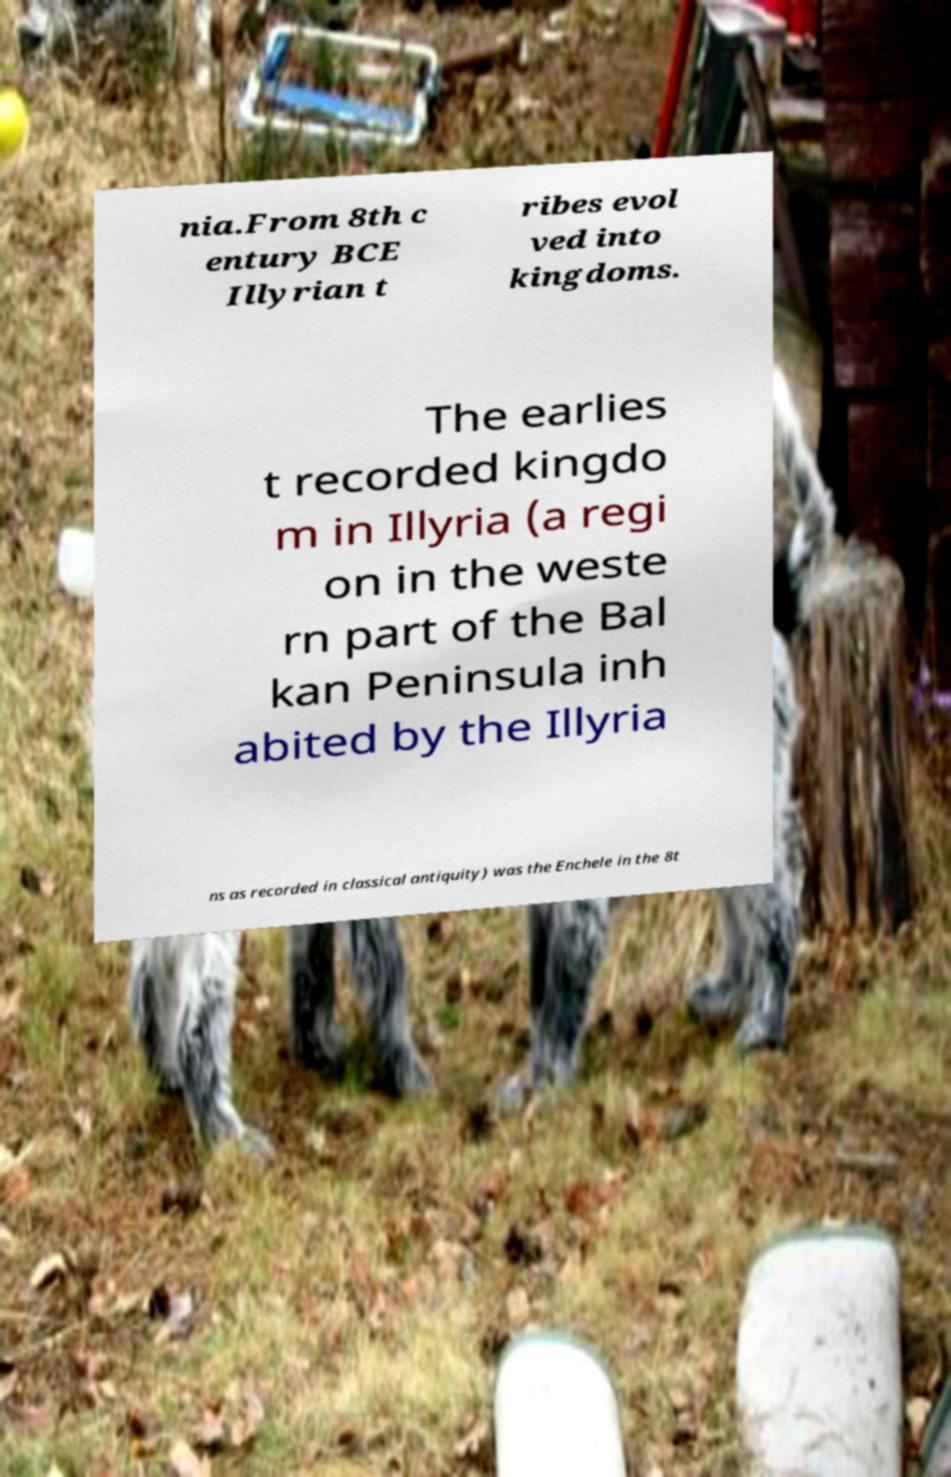There's text embedded in this image that I need extracted. Can you transcribe it verbatim? nia.From 8th c entury BCE Illyrian t ribes evol ved into kingdoms. The earlies t recorded kingdo m in Illyria (a regi on in the weste rn part of the Bal kan Peninsula inh abited by the Illyria ns as recorded in classical antiquity) was the Enchele in the 8t 